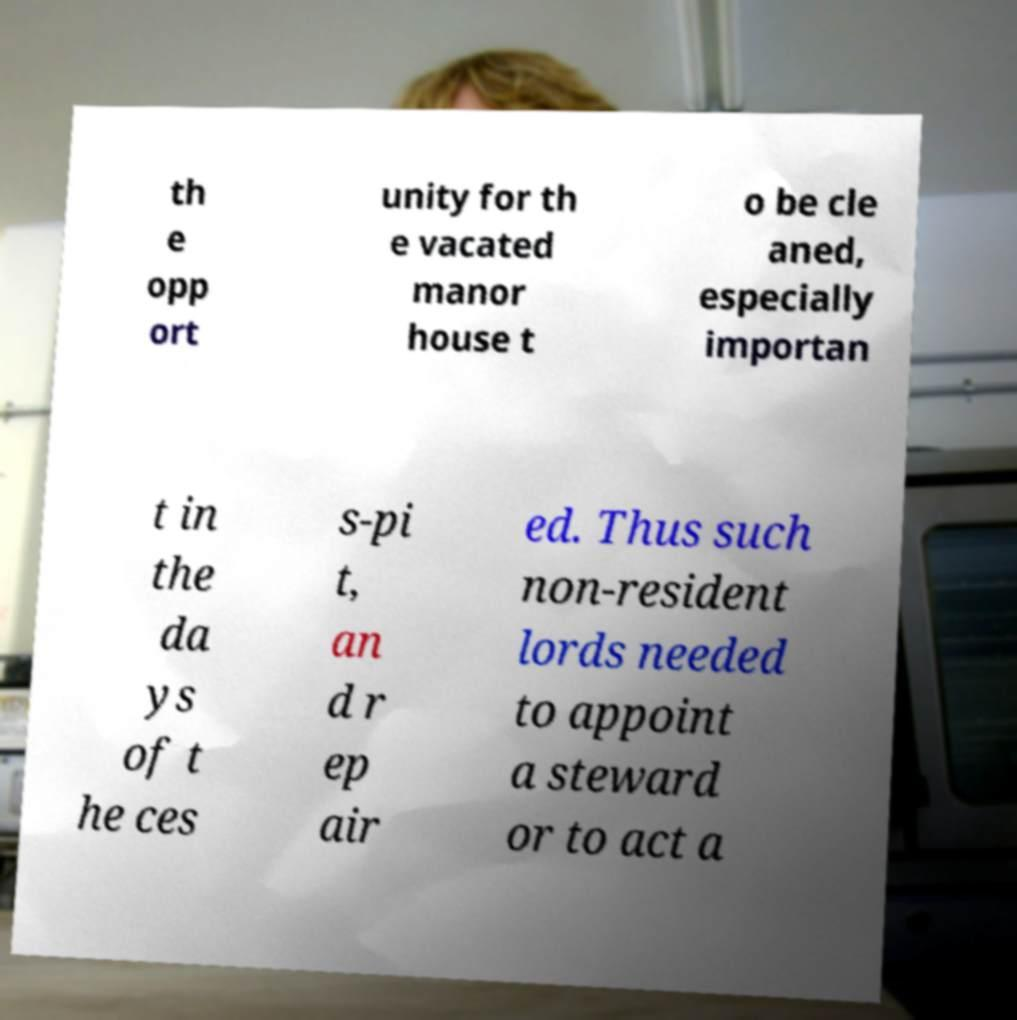Please read and relay the text visible in this image. What does it say? th e opp ort unity for th e vacated manor house t o be cle aned, especially importan t in the da ys of t he ces s-pi t, an d r ep air ed. Thus such non-resident lords needed to appoint a steward or to act a 